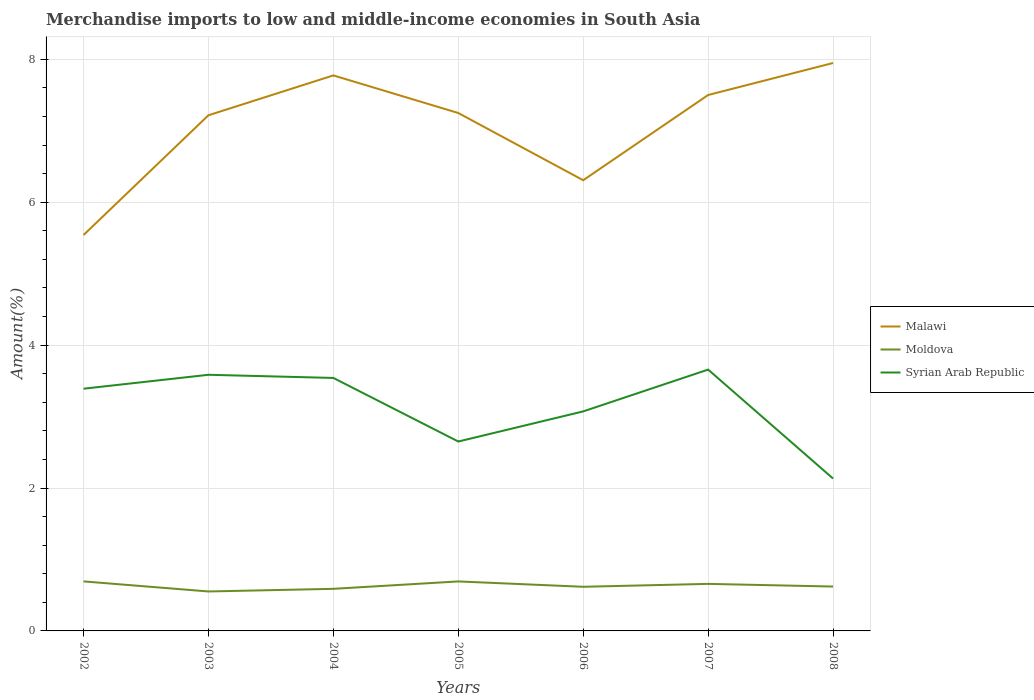Is the number of lines equal to the number of legend labels?
Make the answer very short. Yes. Across all years, what is the maximum percentage of amount earned from merchandise imports in Moldova?
Ensure brevity in your answer.  0.55. What is the total percentage of amount earned from merchandise imports in Malawi in the graph?
Make the answer very short. 0.94. What is the difference between the highest and the second highest percentage of amount earned from merchandise imports in Malawi?
Give a very brief answer. 2.41. How many lines are there?
Ensure brevity in your answer.  3. How many years are there in the graph?
Offer a very short reply. 7. What is the difference between two consecutive major ticks on the Y-axis?
Offer a terse response. 2. Are the values on the major ticks of Y-axis written in scientific E-notation?
Ensure brevity in your answer.  No. Does the graph contain grids?
Give a very brief answer. Yes. Where does the legend appear in the graph?
Your answer should be compact. Center right. How many legend labels are there?
Give a very brief answer. 3. What is the title of the graph?
Provide a succinct answer. Merchandise imports to low and middle-income economies in South Asia. What is the label or title of the X-axis?
Offer a terse response. Years. What is the label or title of the Y-axis?
Give a very brief answer. Amount(%). What is the Amount(%) of Malawi in 2002?
Provide a succinct answer. 5.54. What is the Amount(%) of Moldova in 2002?
Give a very brief answer. 0.69. What is the Amount(%) in Syrian Arab Republic in 2002?
Offer a terse response. 3.39. What is the Amount(%) of Malawi in 2003?
Provide a succinct answer. 7.22. What is the Amount(%) of Moldova in 2003?
Your answer should be very brief. 0.55. What is the Amount(%) of Syrian Arab Republic in 2003?
Offer a very short reply. 3.58. What is the Amount(%) of Malawi in 2004?
Make the answer very short. 7.77. What is the Amount(%) of Moldova in 2004?
Provide a succinct answer. 0.59. What is the Amount(%) of Syrian Arab Republic in 2004?
Keep it short and to the point. 3.54. What is the Amount(%) of Malawi in 2005?
Your answer should be compact. 7.25. What is the Amount(%) of Moldova in 2005?
Ensure brevity in your answer.  0.69. What is the Amount(%) of Syrian Arab Republic in 2005?
Give a very brief answer. 2.65. What is the Amount(%) in Malawi in 2006?
Your response must be concise. 6.31. What is the Amount(%) of Moldova in 2006?
Your answer should be very brief. 0.62. What is the Amount(%) of Syrian Arab Republic in 2006?
Your answer should be very brief. 3.07. What is the Amount(%) in Malawi in 2007?
Provide a succinct answer. 7.5. What is the Amount(%) in Moldova in 2007?
Offer a terse response. 0.66. What is the Amount(%) of Syrian Arab Republic in 2007?
Your answer should be compact. 3.66. What is the Amount(%) of Malawi in 2008?
Give a very brief answer. 7.95. What is the Amount(%) of Moldova in 2008?
Make the answer very short. 0.62. What is the Amount(%) in Syrian Arab Republic in 2008?
Provide a short and direct response. 2.13. Across all years, what is the maximum Amount(%) of Malawi?
Offer a very short reply. 7.95. Across all years, what is the maximum Amount(%) of Moldova?
Your response must be concise. 0.69. Across all years, what is the maximum Amount(%) of Syrian Arab Republic?
Keep it short and to the point. 3.66. Across all years, what is the minimum Amount(%) in Malawi?
Provide a short and direct response. 5.54. Across all years, what is the minimum Amount(%) in Moldova?
Make the answer very short. 0.55. Across all years, what is the minimum Amount(%) of Syrian Arab Republic?
Ensure brevity in your answer.  2.13. What is the total Amount(%) of Malawi in the graph?
Your response must be concise. 49.53. What is the total Amount(%) in Moldova in the graph?
Your answer should be very brief. 4.42. What is the total Amount(%) in Syrian Arab Republic in the graph?
Give a very brief answer. 22.03. What is the difference between the Amount(%) in Malawi in 2002 and that in 2003?
Offer a very short reply. -1.68. What is the difference between the Amount(%) in Moldova in 2002 and that in 2003?
Offer a terse response. 0.14. What is the difference between the Amount(%) of Syrian Arab Republic in 2002 and that in 2003?
Keep it short and to the point. -0.2. What is the difference between the Amount(%) in Malawi in 2002 and that in 2004?
Offer a very short reply. -2.23. What is the difference between the Amount(%) of Moldova in 2002 and that in 2004?
Provide a succinct answer. 0.1. What is the difference between the Amount(%) of Syrian Arab Republic in 2002 and that in 2004?
Provide a short and direct response. -0.15. What is the difference between the Amount(%) of Malawi in 2002 and that in 2005?
Your answer should be compact. -1.71. What is the difference between the Amount(%) of Moldova in 2002 and that in 2005?
Your answer should be very brief. 0. What is the difference between the Amount(%) in Syrian Arab Republic in 2002 and that in 2005?
Give a very brief answer. 0.74. What is the difference between the Amount(%) of Malawi in 2002 and that in 2006?
Provide a short and direct response. -0.77. What is the difference between the Amount(%) of Moldova in 2002 and that in 2006?
Keep it short and to the point. 0.08. What is the difference between the Amount(%) in Syrian Arab Republic in 2002 and that in 2006?
Give a very brief answer. 0.32. What is the difference between the Amount(%) in Malawi in 2002 and that in 2007?
Ensure brevity in your answer.  -1.96. What is the difference between the Amount(%) in Moldova in 2002 and that in 2007?
Your response must be concise. 0.03. What is the difference between the Amount(%) of Syrian Arab Republic in 2002 and that in 2007?
Offer a very short reply. -0.27. What is the difference between the Amount(%) of Malawi in 2002 and that in 2008?
Provide a short and direct response. -2.41. What is the difference between the Amount(%) of Moldova in 2002 and that in 2008?
Provide a succinct answer. 0.07. What is the difference between the Amount(%) in Syrian Arab Republic in 2002 and that in 2008?
Ensure brevity in your answer.  1.26. What is the difference between the Amount(%) in Malawi in 2003 and that in 2004?
Your answer should be very brief. -0.56. What is the difference between the Amount(%) in Moldova in 2003 and that in 2004?
Make the answer very short. -0.04. What is the difference between the Amount(%) of Syrian Arab Republic in 2003 and that in 2004?
Your response must be concise. 0.04. What is the difference between the Amount(%) in Malawi in 2003 and that in 2005?
Your answer should be very brief. -0.03. What is the difference between the Amount(%) in Moldova in 2003 and that in 2005?
Provide a succinct answer. -0.14. What is the difference between the Amount(%) in Syrian Arab Republic in 2003 and that in 2005?
Offer a very short reply. 0.93. What is the difference between the Amount(%) of Malawi in 2003 and that in 2006?
Your response must be concise. 0.91. What is the difference between the Amount(%) in Moldova in 2003 and that in 2006?
Offer a terse response. -0.07. What is the difference between the Amount(%) in Syrian Arab Republic in 2003 and that in 2006?
Your answer should be very brief. 0.51. What is the difference between the Amount(%) of Malawi in 2003 and that in 2007?
Your answer should be compact. -0.28. What is the difference between the Amount(%) of Moldova in 2003 and that in 2007?
Provide a short and direct response. -0.11. What is the difference between the Amount(%) in Syrian Arab Republic in 2003 and that in 2007?
Keep it short and to the point. -0.07. What is the difference between the Amount(%) of Malawi in 2003 and that in 2008?
Give a very brief answer. -0.73. What is the difference between the Amount(%) in Moldova in 2003 and that in 2008?
Provide a short and direct response. -0.07. What is the difference between the Amount(%) in Syrian Arab Republic in 2003 and that in 2008?
Keep it short and to the point. 1.45. What is the difference between the Amount(%) in Malawi in 2004 and that in 2005?
Offer a very short reply. 0.53. What is the difference between the Amount(%) in Moldova in 2004 and that in 2005?
Offer a very short reply. -0.1. What is the difference between the Amount(%) in Syrian Arab Republic in 2004 and that in 2005?
Your answer should be very brief. 0.89. What is the difference between the Amount(%) in Malawi in 2004 and that in 2006?
Your answer should be compact. 1.47. What is the difference between the Amount(%) of Moldova in 2004 and that in 2006?
Keep it short and to the point. -0.03. What is the difference between the Amount(%) of Syrian Arab Republic in 2004 and that in 2006?
Your response must be concise. 0.47. What is the difference between the Amount(%) in Malawi in 2004 and that in 2007?
Provide a succinct answer. 0.27. What is the difference between the Amount(%) in Moldova in 2004 and that in 2007?
Ensure brevity in your answer.  -0.07. What is the difference between the Amount(%) in Syrian Arab Republic in 2004 and that in 2007?
Provide a succinct answer. -0.12. What is the difference between the Amount(%) in Malawi in 2004 and that in 2008?
Make the answer very short. -0.17. What is the difference between the Amount(%) of Moldova in 2004 and that in 2008?
Provide a short and direct response. -0.03. What is the difference between the Amount(%) in Syrian Arab Republic in 2004 and that in 2008?
Your answer should be very brief. 1.41. What is the difference between the Amount(%) of Malawi in 2005 and that in 2006?
Offer a very short reply. 0.94. What is the difference between the Amount(%) of Moldova in 2005 and that in 2006?
Ensure brevity in your answer.  0.07. What is the difference between the Amount(%) in Syrian Arab Republic in 2005 and that in 2006?
Provide a short and direct response. -0.42. What is the difference between the Amount(%) of Malawi in 2005 and that in 2007?
Offer a very short reply. -0.25. What is the difference between the Amount(%) in Moldova in 2005 and that in 2007?
Offer a terse response. 0.03. What is the difference between the Amount(%) of Syrian Arab Republic in 2005 and that in 2007?
Provide a short and direct response. -1.01. What is the difference between the Amount(%) of Malawi in 2005 and that in 2008?
Offer a terse response. -0.7. What is the difference between the Amount(%) in Moldova in 2005 and that in 2008?
Your answer should be very brief. 0.07. What is the difference between the Amount(%) in Syrian Arab Republic in 2005 and that in 2008?
Your response must be concise. 0.52. What is the difference between the Amount(%) of Malawi in 2006 and that in 2007?
Your response must be concise. -1.19. What is the difference between the Amount(%) of Moldova in 2006 and that in 2007?
Keep it short and to the point. -0.04. What is the difference between the Amount(%) in Syrian Arab Republic in 2006 and that in 2007?
Your answer should be very brief. -0.58. What is the difference between the Amount(%) in Malawi in 2006 and that in 2008?
Your response must be concise. -1.64. What is the difference between the Amount(%) in Moldova in 2006 and that in 2008?
Offer a terse response. -0. What is the difference between the Amount(%) in Syrian Arab Republic in 2006 and that in 2008?
Keep it short and to the point. 0.94. What is the difference between the Amount(%) in Malawi in 2007 and that in 2008?
Offer a very short reply. -0.45. What is the difference between the Amount(%) in Moldova in 2007 and that in 2008?
Make the answer very short. 0.04. What is the difference between the Amount(%) of Syrian Arab Republic in 2007 and that in 2008?
Keep it short and to the point. 1.52. What is the difference between the Amount(%) of Malawi in 2002 and the Amount(%) of Moldova in 2003?
Your answer should be compact. 4.99. What is the difference between the Amount(%) in Malawi in 2002 and the Amount(%) in Syrian Arab Republic in 2003?
Provide a short and direct response. 1.96. What is the difference between the Amount(%) of Moldova in 2002 and the Amount(%) of Syrian Arab Republic in 2003?
Give a very brief answer. -2.89. What is the difference between the Amount(%) in Malawi in 2002 and the Amount(%) in Moldova in 2004?
Your response must be concise. 4.95. What is the difference between the Amount(%) in Malawi in 2002 and the Amount(%) in Syrian Arab Republic in 2004?
Ensure brevity in your answer.  2. What is the difference between the Amount(%) of Moldova in 2002 and the Amount(%) of Syrian Arab Republic in 2004?
Provide a short and direct response. -2.85. What is the difference between the Amount(%) of Malawi in 2002 and the Amount(%) of Moldova in 2005?
Make the answer very short. 4.85. What is the difference between the Amount(%) of Malawi in 2002 and the Amount(%) of Syrian Arab Republic in 2005?
Make the answer very short. 2.89. What is the difference between the Amount(%) of Moldova in 2002 and the Amount(%) of Syrian Arab Republic in 2005?
Make the answer very short. -1.96. What is the difference between the Amount(%) in Malawi in 2002 and the Amount(%) in Moldova in 2006?
Offer a terse response. 4.92. What is the difference between the Amount(%) of Malawi in 2002 and the Amount(%) of Syrian Arab Republic in 2006?
Make the answer very short. 2.47. What is the difference between the Amount(%) of Moldova in 2002 and the Amount(%) of Syrian Arab Republic in 2006?
Provide a short and direct response. -2.38. What is the difference between the Amount(%) in Malawi in 2002 and the Amount(%) in Moldova in 2007?
Your answer should be compact. 4.88. What is the difference between the Amount(%) in Malawi in 2002 and the Amount(%) in Syrian Arab Republic in 2007?
Offer a very short reply. 1.88. What is the difference between the Amount(%) in Moldova in 2002 and the Amount(%) in Syrian Arab Republic in 2007?
Provide a succinct answer. -2.96. What is the difference between the Amount(%) in Malawi in 2002 and the Amount(%) in Moldova in 2008?
Your answer should be very brief. 4.92. What is the difference between the Amount(%) in Malawi in 2002 and the Amount(%) in Syrian Arab Republic in 2008?
Offer a terse response. 3.41. What is the difference between the Amount(%) of Moldova in 2002 and the Amount(%) of Syrian Arab Republic in 2008?
Offer a terse response. -1.44. What is the difference between the Amount(%) of Malawi in 2003 and the Amount(%) of Moldova in 2004?
Provide a succinct answer. 6.63. What is the difference between the Amount(%) in Malawi in 2003 and the Amount(%) in Syrian Arab Republic in 2004?
Your answer should be compact. 3.68. What is the difference between the Amount(%) in Moldova in 2003 and the Amount(%) in Syrian Arab Republic in 2004?
Make the answer very short. -2.99. What is the difference between the Amount(%) in Malawi in 2003 and the Amount(%) in Moldova in 2005?
Provide a succinct answer. 6.52. What is the difference between the Amount(%) in Malawi in 2003 and the Amount(%) in Syrian Arab Republic in 2005?
Ensure brevity in your answer.  4.57. What is the difference between the Amount(%) in Moldova in 2003 and the Amount(%) in Syrian Arab Republic in 2005?
Offer a terse response. -2.1. What is the difference between the Amount(%) of Malawi in 2003 and the Amount(%) of Moldova in 2006?
Your answer should be very brief. 6.6. What is the difference between the Amount(%) in Malawi in 2003 and the Amount(%) in Syrian Arab Republic in 2006?
Your answer should be very brief. 4.14. What is the difference between the Amount(%) of Moldova in 2003 and the Amount(%) of Syrian Arab Republic in 2006?
Your answer should be compact. -2.52. What is the difference between the Amount(%) in Malawi in 2003 and the Amount(%) in Moldova in 2007?
Offer a terse response. 6.56. What is the difference between the Amount(%) in Malawi in 2003 and the Amount(%) in Syrian Arab Republic in 2007?
Offer a terse response. 3.56. What is the difference between the Amount(%) of Moldova in 2003 and the Amount(%) of Syrian Arab Republic in 2007?
Offer a very short reply. -3.1. What is the difference between the Amount(%) of Malawi in 2003 and the Amount(%) of Moldova in 2008?
Provide a succinct answer. 6.6. What is the difference between the Amount(%) in Malawi in 2003 and the Amount(%) in Syrian Arab Republic in 2008?
Make the answer very short. 5.08. What is the difference between the Amount(%) in Moldova in 2003 and the Amount(%) in Syrian Arab Republic in 2008?
Provide a succinct answer. -1.58. What is the difference between the Amount(%) of Malawi in 2004 and the Amount(%) of Moldova in 2005?
Your answer should be very brief. 7.08. What is the difference between the Amount(%) of Malawi in 2004 and the Amount(%) of Syrian Arab Republic in 2005?
Ensure brevity in your answer.  5.12. What is the difference between the Amount(%) in Moldova in 2004 and the Amount(%) in Syrian Arab Republic in 2005?
Ensure brevity in your answer.  -2.06. What is the difference between the Amount(%) of Malawi in 2004 and the Amount(%) of Moldova in 2006?
Offer a terse response. 7.16. What is the difference between the Amount(%) in Malawi in 2004 and the Amount(%) in Syrian Arab Republic in 2006?
Provide a short and direct response. 4.7. What is the difference between the Amount(%) in Moldova in 2004 and the Amount(%) in Syrian Arab Republic in 2006?
Give a very brief answer. -2.48. What is the difference between the Amount(%) of Malawi in 2004 and the Amount(%) of Moldova in 2007?
Your response must be concise. 7.12. What is the difference between the Amount(%) of Malawi in 2004 and the Amount(%) of Syrian Arab Republic in 2007?
Your response must be concise. 4.12. What is the difference between the Amount(%) in Moldova in 2004 and the Amount(%) in Syrian Arab Republic in 2007?
Make the answer very short. -3.07. What is the difference between the Amount(%) of Malawi in 2004 and the Amount(%) of Moldova in 2008?
Provide a succinct answer. 7.15. What is the difference between the Amount(%) in Malawi in 2004 and the Amount(%) in Syrian Arab Republic in 2008?
Make the answer very short. 5.64. What is the difference between the Amount(%) in Moldova in 2004 and the Amount(%) in Syrian Arab Republic in 2008?
Keep it short and to the point. -1.54. What is the difference between the Amount(%) in Malawi in 2005 and the Amount(%) in Moldova in 2006?
Make the answer very short. 6.63. What is the difference between the Amount(%) of Malawi in 2005 and the Amount(%) of Syrian Arab Republic in 2006?
Provide a short and direct response. 4.18. What is the difference between the Amount(%) in Moldova in 2005 and the Amount(%) in Syrian Arab Republic in 2006?
Offer a very short reply. -2.38. What is the difference between the Amount(%) in Malawi in 2005 and the Amount(%) in Moldova in 2007?
Offer a terse response. 6.59. What is the difference between the Amount(%) in Malawi in 2005 and the Amount(%) in Syrian Arab Republic in 2007?
Provide a succinct answer. 3.59. What is the difference between the Amount(%) in Moldova in 2005 and the Amount(%) in Syrian Arab Republic in 2007?
Offer a very short reply. -2.96. What is the difference between the Amount(%) of Malawi in 2005 and the Amount(%) of Moldova in 2008?
Ensure brevity in your answer.  6.63. What is the difference between the Amount(%) in Malawi in 2005 and the Amount(%) in Syrian Arab Republic in 2008?
Ensure brevity in your answer.  5.12. What is the difference between the Amount(%) of Moldova in 2005 and the Amount(%) of Syrian Arab Republic in 2008?
Provide a short and direct response. -1.44. What is the difference between the Amount(%) of Malawi in 2006 and the Amount(%) of Moldova in 2007?
Provide a short and direct response. 5.65. What is the difference between the Amount(%) in Malawi in 2006 and the Amount(%) in Syrian Arab Republic in 2007?
Your answer should be compact. 2.65. What is the difference between the Amount(%) of Moldova in 2006 and the Amount(%) of Syrian Arab Republic in 2007?
Make the answer very short. -3.04. What is the difference between the Amount(%) in Malawi in 2006 and the Amount(%) in Moldova in 2008?
Provide a succinct answer. 5.69. What is the difference between the Amount(%) of Malawi in 2006 and the Amount(%) of Syrian Arab Republic in 2008?
Your response must be concise. 4.17. What is the difference between the Amount(%) of Moldova in 2006 and the Amount(%) of Syrian Arab Republic in 2008?
Offer a very short reply. -1.51. What is the difference between the Amount(%) of Malawi in 2007 and the Amount(%) of Moldova in 2008?
Give a very brief answer. 6.88. What is the difference between the Amount(%) in Malawi in 2007 and the Amount(%) in Syrian Arab Republic in 2008?
Provide a succinct answer. 5.37. What is the difference between the Amount(%) in Moldova in 2007 and the Amount(%) in Syrian Arab Republic in 2008?
Ensure brevity in your answer.  -1.47. What is the average Amount(%) in Malawi per year?
Provide a short and direct response. 7.08. What is the average Amount(%) of Moldova per year?
Your response must be concise. 0.63. What is the average Amount(%) in Syrian Arab Republic per year?
Your answer should be compact. 3.15. In the year 2002, what is the difference between the Amount(%) of Malawi and Amount(%) of Moldova?
Provide a short and direct response. 4.85. In the year 2002, what is the difference between the Amount(%) of Malawi and Amount(%) of Syrian Arab Republic?
Offer a very short reply. 2.15. In the year 2002, what is the difference between the Amount(%) in Moldova and Amount(%) in Syrian Arab Republic?
Keep it short and to the point. -2.7. In the year 2003, what is the difference between the Amount(%) of Malawi and Amount(%) of Moldova?
Offer a terse response. 6.66. In the year 2003, what is the difference between the Amount(%) in Malawi and Amount(%) in Syrian Arab Republic?
Keep it short and to the point. 3.63. In the year 2003, what is the difference between the Amount(%) in Moldova and Amount(%) in Syrian Arab Republic?
Keep it short and to the point. -3.03. In the year 2004, what is the difference between the Amount(%) in Malawi and Amount(%) in Moldova?
Give a very brief answer. 7.18. In the year 2004, what is the difference between the Amount(%) of Malawi and Amount(%) of Syrian Arab Republic?
Offer a very short reply. 4.23. In the year 2004, what is the difference between the Amount(%) of Moldova and Amount(%) of Syrian Arab Republic?
Offer a very short reply. -2.95. In the year 2005, what is the difference between the Amount(%) of Malawi and Amount(%) of Moldova?
Make the answer very short. 6.56. In the year 2005, what is the difference between the Amount(%) of Malawi and Amount(%) of Syrian Arab Republic?
Offer a terse response. 4.6. In the year 2005, what is the difference between the Amount(%) of Moldova and Amount(%) of Syrian Arab Republic?
Your answer should be compact. -1.96. In the year 2006, what is the difference between the Amount(%) of Malawi and Amount(%) of Moldova?
Keep it short and to the point. 5.69. In the year 2006, what is the difference between the Amount(%) of Malawi and Amount(%) of Syrian Arab Republic?
Offer a very short reply. 3.24. In the year 2006, what is the difference between the Amount(%) in Moldova and Amount(%) in Syrian Arab Republic?
Make the answer very short. -2.45. In the year 2007, what is the difference between the Amount(%) of Malawi and Amount(%) of Moldova?
Your response must be concise. 6.84. In the year 2007, what is the difference between the Amount(%) of Malawi and Amount(%) of Syrian Arab Republic?
Provide a short and direct response. 3.84. In the year 2007, what is the difference between the Amount(%) of Moldova and Amount(%) of Syrian Arab Republic?
Make the answer very short. -3. In the year 2008, what is the difference between the Amount(%) of Malawi and Amount(%) of Moldova?
Offer a terse response. 7.33. In the year 2008, what is the difference between the Amount(%) in Malawi and Amount(%) in Syrian Arab Republic?
Ensure brevity in your answer.  5.82. In the year 2008, what is the difference between the Amount(%) of Moldova and Amount(%) of Syrian Arab Republic?
Ensure brevity in your answer.  -1.51. What is the ratio of the Amount(%) of Malawi in 2002 to that in 2003?
Your answer should be very brief. 0.77. What is the ratio of the Amount(%) in Moldova in 2002 to that in 2003?
Offer a terse response. 1.26. What is the ratio of the Amount(%) of Syrian Arab Republic in 2002 to that in 2003?
Your response must be concise. 0.95. What is the ratio of the Amount(%) in Malawi in 2002 to that in 2004?
Offer a terse response. 0.71. What is the ratio of the Amount(%) of Moldova in 2002 to that in 2004?
Your response must be concise. 1.18. What is the ratio of the Amount(%) in Syrian Arab Republic in 2002 to that in 2004?
Offer a very short reply. 0.96. What is the ratio of the Amount(%) in Malawi in 2002 to that in 2005?
Ensure brevity in your answer.  0.76. What is the ratio of the Amount(%) in Syrian Arab Republic in 2002 to that in 2005?
Your answer should be compact. 1.28. What is the ratio of the Amount(%) in Malawi in 2002 to that in 2006?
Make the answer very short. 0.88. What is the ratio of the Amount(%) of Moldova in 2002 to that in 2006?
Offer a very short reply. 1.12. What is the ratio of the Amount(%) of Syrian Arab Republic in 2002 to that in 2006?
Your answer should be very brief. 1.1. What is the ratio of the Amount(%) in Malawi in 2002 to that in 2007?
Keep it short and to the point. 0.74. What is the ratio of the Amount(%) in Moldova in 2002 to that in 2007?
Ensure brevity in your answer.  1.05. What is the ratio of the Amount(%) in Syrian Arab Republic in 2002 to that in 2007?
Keep it short and to the point. 0.93. What is the ratio of the Amount(%) in Malawi in 2002 to that in 2008?
Offer a terse response. 0.7. What is the ratio of the Amount(%) in Moldova in 2002 to that in 2008?
Keep it short and to the point. 1.12. What is the ratio of the Amount(%) of Syrian Arab Republic in 2002 to that in 2008?
Offer a terse response. 1.59. What is the ratio of the Amount(%) of Malawi in 2003 to that in 2004?
Your answer should be very brief. 0.93. What is the ratio of the Amount(%) of Moldova in 2003 to that in 2004?
Keep it short and to the point. 0.94. What is the ratio of the Amount(%) of Syrian Arab Republic in 2003 to that in 2004?
Provide a short and direct response. 1.01. What is the ratio of the Amount(%) of Malawi in 2003 to that in 2005?
Provide a short and direct response. 1. What is the ratio of the Amount(%) of Moldova in 2003 to that in 2005?
Your answer should be very brief. 0.8. What is the ratio of the Amount(%) of Syrian Arab Republic in 2003 to that in 2005?
Provide a succinct answer. 1.35. What is the ratio of the Amount(%) of Malawi in 2003 to that in 2006?
Offer a very short reply. 1.14. What is the ratio of the Amount(%) in Moldova in 2003 to that in 2006?
Ensure brevity in your answer.  0.89. What is the ratio of the Amount(%) of Syrian Arab Republic in 2003 to that in 2006?
Offer a very short reply. 1.17. What is the ratio of the Amount(%) in Malawi in 2003 to that in 2007?
Give a very brief answer. 0.96. What is the ratio of the Amount(%) in Moldova in 2003 to that in 2007?
Give a very brief answer. 0.84. What is the ratio of the Amount(%) in Syrian Arab Republic in 2003 to that in 2007?
Give a very brief answer. 0.98. What is the ratio of the Amount(%) in Malawi in 2003 to that in 2008?
Offer a very short reply. 0.91. What is the ratio of the Amount(%) of Moldova in 2003 to that in 2008?
Offer a very short reply. 0.89. What is the ratio of the Amount(%) of Syrian Arab Republic in 2003 to that in 2008?
Your response must be concise. 1.68. What is the ratio of the Amount(%) of Malawi in 2004 to that in 2005?
Your answer should be compact. 1.07. What is the ratio of the Amount(%) in Moldova in 2004 to that in 2005?
Provide a succinct answer. 0.85. What is the ratio of the Amount(%) in Syrian Arab Republic in 2004 to that in 2005?
Ensure brevity in your answer.  1.34. What is the ratio of the Amount(%) of Malawi in 2004 to that in 2006?
Give a very brief answer. 1.23. What is the ratio of the Amount(%) of Moldova in 2004 to that in 2006?
Ensure brevity in your answer.  0.95. What is the ratio of the Amount(%) in Syrian Arab Republic in 2004 to that in 2006?
Give a very brief answer. 1.15. What is the ratio of the Amount(%) of Malawi in 2004 to that in 2007?
Give a very brief answer. 1.04. What is the ratio of the Amount(%) in Moldova in 2004 to that in 2007?
Make the answer very short. 0.89. What is the ratio of the Amount(%) in Syrian Arab Republic in 2004 to that in 2007?
Ensure brevity in your answer.  0.97. What is the ratio of the Amount(%) in Malawi in 2004 to that in 2008?
Your answer should be very brief. 0.98. What is the ratio of the Amount(%) of Moldova in 2004 to that in 2008?
Ensure brevity in your answer.  0.95. What is the ratio of the Amount(%) of Syrian Arab Republic in 2004 to that in 2008?
Offer a very short reply. 1.66. What is the ratio of the Amount(%) of Malawi in 2005 to that in 2006?
Ensure brevity in your answer.  1.15. What is the ratio of the Amount(%) in Moldova in 2005 to that in 2006?
Offer a very short reply. 1.12. What is the ratio of the Amount(%) in Syrian Arab Republic in 2005 to that in 2006?
Your response must be concise. 0.86. What is the ratio of the Amount(%) of Malawi in 2005 to that in 2007?
Provide a succinct answer. 0.97. What is the ratio of the Amount(%) in Moldova in 2005 to that in 2007?
Offer a terse response. 1.05. What is the ratio of the Amount(%) in Syrian Arab Republic in 2005 to that in 2007?
Make the answer very short. 0.72. What is the ratio of the Amount(%) in Malawi in 2005 to that in 2008?
Offer a very short reply. 0.91. What is the ratio of the Amount(%) in Moldova in 2005 to that in 2008?
Your response must be concise. 1.12. What is the ratio of the Amount(%) in Syrian Arab Republic in 2005 to that in 2008?
Your answer should be very brief. 1.24. What is the ratio of the Amount(%) in Malawi in 2006 to that in 2007?
Ensure brevity in your answer.  0.84. What is the ratio of the Amount(%) in Moldova in 2006 to that in 2007?
Your answer should be compact. 0.94. What is the ratio of the Amount(%) of Syrian Arab Republic in 2006 to that in 2007?
Make the answer very short. 0.84. What is the ratio of the Amount(%) in Malawi in 2006 to that in 2008?
Offer a very short reply. 0.79. What is the ratio of the Amount(%) in Syrian Arab Republic in 2006 to that in 2008?
Give a very brief answer. 1.44. What is the ratio of the Amount(%) in Malawi in 2007 to that in 2008?
Provide a succinct answer. 0.94. What is the ratio of the Amount(%) of Moldova in 2007 to that in 2008?
Provide a short and direct response. 1.06. What is the ratio of the Amount(%) of Syrian Arab Republic in 2007 to that in 2008?
Your answer should be very brief. 1.72. What is the difference between the highest and the second highest Amount(%) in Malawi?
Your answer should be very brief. 0.17. What is the difference between the highest and the second highest Amount(%) of Syrian Arab Republic?
Keep it short and to the point. 0.07. What is the difference between the highest and the lowest Amount(%) in Malawi?
Provide a succinct answer. 2.41. What is the difference between the highest and the lowest Amount(%) of Moldova?
Your answer should be very brief. 0.14. What is the difference between the highest and the lowest Amount(%) of Syrian Arab Republic?
Your answer should be compact. 1.52. 